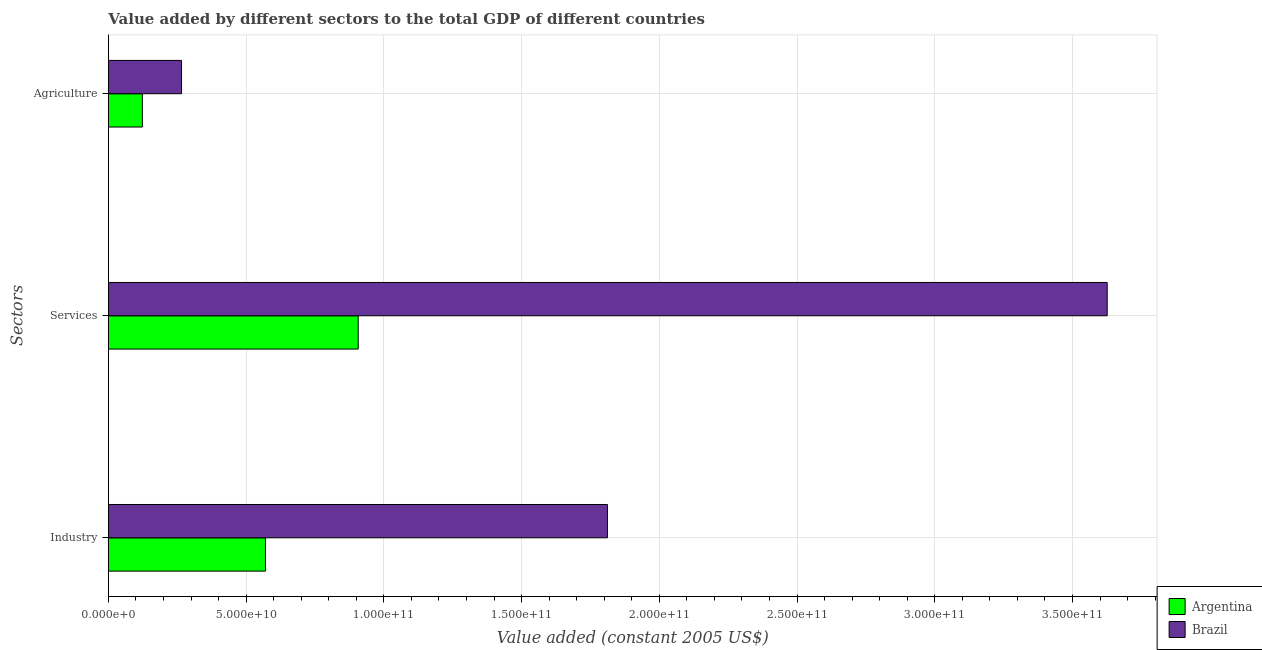How many different coloured bars are there?
Keep it short and to the point. 2. What is the label of the 3rd group of bars from the top?
Offer a very short reply. Industry. What is the value added by industrial sector in Argentina?
Make the answer very short. 5.70e+1. Across all countries, what is the maximum value added by industrial sector?
Ensure brevity in your answer.  1.81e+11. Across all countries, what is the minimum value added by industrial sector?
Make the answer very short. 5.70e+1. In which country was the value added by industrial sector minimum?
Provide a short and direct response. Argentina. What is the total value added by services in the graph?
Provide a succinct answer. 4.53e+11. What is the difference between the value added by services in Argentina and that in Brazil?
Provide a short and direct response. -2.72e+11. What is the difference between the value added by industrial sector in Argentina and the value added by services in Brazil?
Provide a succinct answer. -3.06e+11. What is the average value added by agricultural sector per country?
Make the answer very short. 1.94e+1. What is the difference between the value added by services and value added by agricultural sector in Brazil?
Keep it short and to the point. 3.36e+11. In how many countries, is the value added by industrial sector greater than 60000000000 US$?
Provide a succinct answer. 1. What is the ratio of the value added by services in Brazil to that in Argentina?
Provide a short and direct response. 4. Is the value added by industrial sector in Argentina less than that in Brazil?
Ensure brevity in your answer.  Yes. What is the difference between the highest and the second highest value added by industrial sector?
Offer a very short reply. 1.24e+11. What is the difference between the highest and the lowest value added by agricultural sector?
Offer a very short reply. 1.42e+1. In how many countries, is the value added by services greater than the average value added by services taken over all countries?
Make the answer very short. 1. What does the 1st bar from the bottom in Agriculture represents?
Make the answer very short. Argentina. How many countries are there in the graph?
Provide a short and direct response. 2. Does the graph contain any zero values?
Provide a succinct answer. No. Where does the legend appear in the graph?
Your response must be concise. Bottom right. How many legend labels are there?
Your answer should be very brief. 2. How are the legend labels stacked?
Your response must be concise. Vertical. What is the title of the graph?
Make the answer very short. Value added by different sectors to the total GDP of different countries. What is the label or title of the X-axis?
Ensure brevity in your answer.  Value added (constant 2005 US$). What is the label or title of the Y-axis?
Make the answer very short. Sectors. What is the Value added (constant 2005 US$) in Argentina in Industry?
Your answer should be compact. 5.70e+1. What is the Value added (constant 2005 US$) in Brazil in Industry?
Your answer should be compact. 1.81e+11. What is the Value added (constant 2005 US$) in Argentina in Services?
Give a very brief answer. 9.07e+1. What is the Value added (constant 2005 US$) in Brazil in Services?
Ensure brevity in your answer.  3.63e+11. What is the Value added (constant 2005 US$) of Argentina in Agriculture?
Keep it short and to the point. 1.23e+1. What is the Value added (constant 2005 US$) of Brazil in Agriculture?
Your answer should be very brief. 2.65e+1. Across all Sectors, what is the maximum Value added (constant 2005 US$) of Argentina?
Provide a succinct answer. 9.07e+1. Across all Sectors, what is the maximum Value added (constant 2005 US$) of Brazil?
Ensure brevity in your answer.  3.63e+11. Across all Sectors, what is the minimum Value added (constant 2005 US$) of Argentina?
Your answer should be very brief. 1.23e+1. Across all Sectors, what is the minimum Value added (constant 2005 US$) in Brazil?
Your answer should be very brief. 2.65e+1. What is the total Value added (constant 2005 US$) of Argentina in the graph?
Offer a very short reply. 1.60e+11. What is the total Value added (constant 2005 US$) in Brazil in the graph?
Your answer should be very brief. 5.70e+11. What is the difference between the Value added (constant 2005 US$) in Argentina in Industry and that in Services?
Your answer should be very brief. -3.37e+1. What is the difference between the Value added (constant 2005 US$) of Brazil in Industry and that in Services?
Provide a succinct answer. -1.81e+11. What is the difference between the Value added (constant 2005 US$) of Argentina in Industry and that in Agriculture?
Provide a short and direct response. 4.47e+1. What is the difference between the Value added (constant 2005 US$) of Brazil in Industry and that in Agriculture?
Ensure brevity in your answer.  1.55e+11. What is the difference between the Value added (constant 2005 US$) of Argentina in Services and that in Agriculture?
Provide a succinct answer. 7.84e+1. What is the difference between the Value added (constant 2005 US$) of Brazil in Services and that in Agriculture?
Your answer should be very brief. 3.36e+11. What is the difference between the Value added (constant 2005 US$) of Argentina in Industry and the Value added (constant 2005 US$) of Brazil in Services?
Offer a terse response. -3.06e+11. What is the difference between the Value added (constant 2005 US$) in Argentina in Industry and the Value added (constant 2005 US$) in Brazil in Agriculture?
Give a very brief answer. 3.05e+1. What is the difference between the Value added (constant 2005 US$) in Argentina in Services and the Value added (constant 2005 US$) in Brazil in Agriculture?
Offer a terse response. 6.41e+1. What is the average Value added (constant 2005 US$) of Argentina per Sectors?
Make the answer very short. 5.33e+1. What is the average Value added (constant 2005 US$) in Brazil per Sectors?
Give a very brief answer. 1.90e+11. What is the difference between the Value added (constant 2005 US$) of Argentina and Value added (constant 2005 US$) of Brazil in Industry?
Ensure brevity in your answer.  -1.24e+11. What is the difference between the Value added (constant 2005 US$) in Argentina and Value added (constant 2005 US$) in Brazil in Services?
Your response must be concise. -2.72e+11. What is the difference between the Value added (constant 2005 US$) in Argentina and Value added (constant 2005 US$) in Brazil in Agriculture?
Provide a short and direct response. -1.42e+1. What is the ratio of the Value added (constant 2005 US$) in Argentina in Industry to that in Services?
Your answer should be very brief. 0.63. What is the ratio of the Value added (constant 2005 US$) in Brazil in Industry to that in Services?
Offer a terse response. 0.5. What is the ratio of the Value added (constant 2005 US$) of Argentina in Industry to that in Agriculture?
Your response must be concise. 4.63. What is the ratio of the Value added (constant 2005 US$) in Brazil in Industry to that in Agriculture?
Your answer should be compact. 6.83. What is the ratio of the Value added (constant 2005 US$) in Argentina in Services to that in Agriculture?
Offer a very short reply. 7.36. What is the ratio of the Value added (constant 2005 US$) of Brazil in Services to that in Agriculture?
Provide a succinct answer. 13.66. What is the difference between the highest and the second highest Value added (constant 2005 US$) of Argentina?
Offer a very short reply. 3.37e+1. What is the difference between the highest and the second highest Value added (constant 2005 US$) of Brazil?
Provide a succinct answer. 1.81e+11. What is the difference between the highest and the lowest Value added (constant 2005 US$) in Argentina?
Ensure brevity in your answer.  7.84e+1. What is the difference between the highest and the lowest Value added (constant 2005 US$) of Brazil?
Provide a succinct answer. 3.36e+11. 